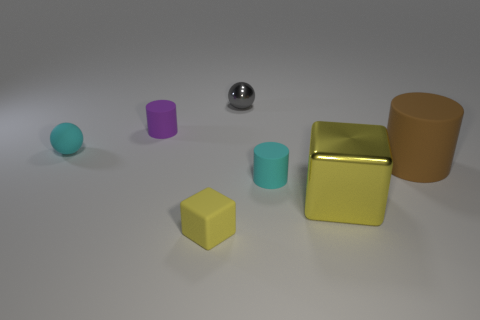There is a small rubber cylinder that is to the left of the small rubber block; what is its color?
Ensure brevity in your answer.  Purple. How many other objects are the same color as the rubber cube?
Provide a succinct answer. 1. Are there any other things that have the same size as the gray thing?
Your answer should be compact. Yes. Is the size of the yellow cube that is on the right side of the yellow matte cube the same as the small gray sphere?
Ensure brevity in your answer.  No. What is the small ball behind the tiny cyan matte sphere made of?
Your response must be concise. Metal. Is there anything else that is the same shape as the large matte thing?
Keep it short and to the point. Yes. How many matte objects are large brown cylinders or blocks?
Your answer should be compact. 2. Is the number of big brown cylinders on the right side of the gray thing less than the number of large metallic cubes?
Keep it short and to the point. No. What shape is the yellow object in front of the metal object that is in front of the cyan object in front of the brown object?
Provide a short and direct response. Cube. Is the big matte object the same color as the small rubber cube?
Provide a succinct answer. No. 